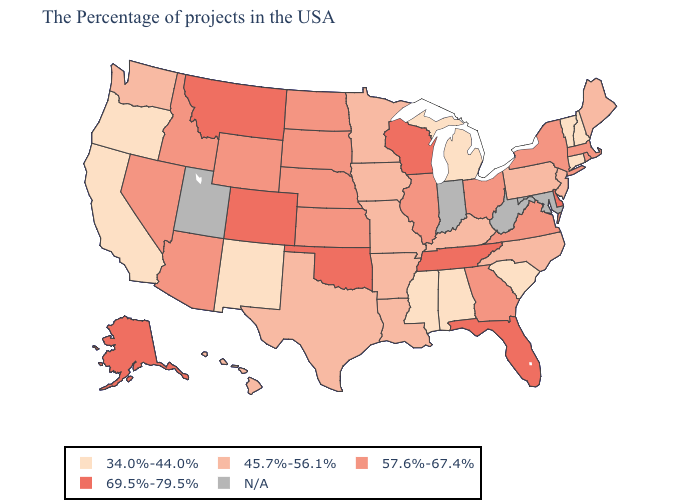What is the lowest value in states that border Oregon?
Keep it brief. 34.0%-44.0%. Name the states that have a value in the range 45.7%-56.1%?
Keep it brief. Maine, New Jersey, Pennsylvania, North Carolina, Kentucky, Louisiana, Missouri, Arkansas, Minnesota, Iowa, Texas, Washington, Hawaii. What is the lowest value in the Northeast?
Concise answer only. 34.0%-44.0%. What is the value of Mississippi?
Short answer required. 34.0%-44.0%. Name the states that have a value in the range 45.7%-56.1%?
Answer briefly. Maine, New Jersey, Pennsylvania, North Carolina, Kentucky, Louisiana, Missouri, Arkansas, Minnesota, Iowa, Texas, Washington, Hawaii. Name the states that have a value in the range 57.6%-67.4%?
Quick response, please. Massachusetts, Rhode Island, New York, Virginia, Ohio, Georgia, Illinois, Kansas, Nebraska, South Dakota, North Dakota, Wyoming, Arizona, Idaho, Nevada. What is the value of Delaware?
Write a very short answer. 69.5%-79.5%. Does Colorado have the highest value in the West?
Give a very brief answer. Yes. What is the value of Oklahoma?
Write a very short answer. 69.5%-79.5%. Which states have the highest value in the USA?
Concise answer only. Delaware, Florida, Tennessee, Wisconsin, Oklahoma, Colorado, Montana, Alaska. How many symbols are there in the legend?
Be succinct. 5. Name the states that have a value in the range 69.5%-79.5%?
Concise answer only. Delaware, Florida, Tennessee, Wisconsin, Oklahoma, Colorado, Montana, Alaska. Does Idaho have the lowest value in the USA?
Keep it brief. No. Which states have the lowest value in the USA?
Give a very brief answer. New Hampshire, Vermont, Connecticut, South Carolina, Michigan, Alabama, Mississippi, New Mexico, California, Oregon. 